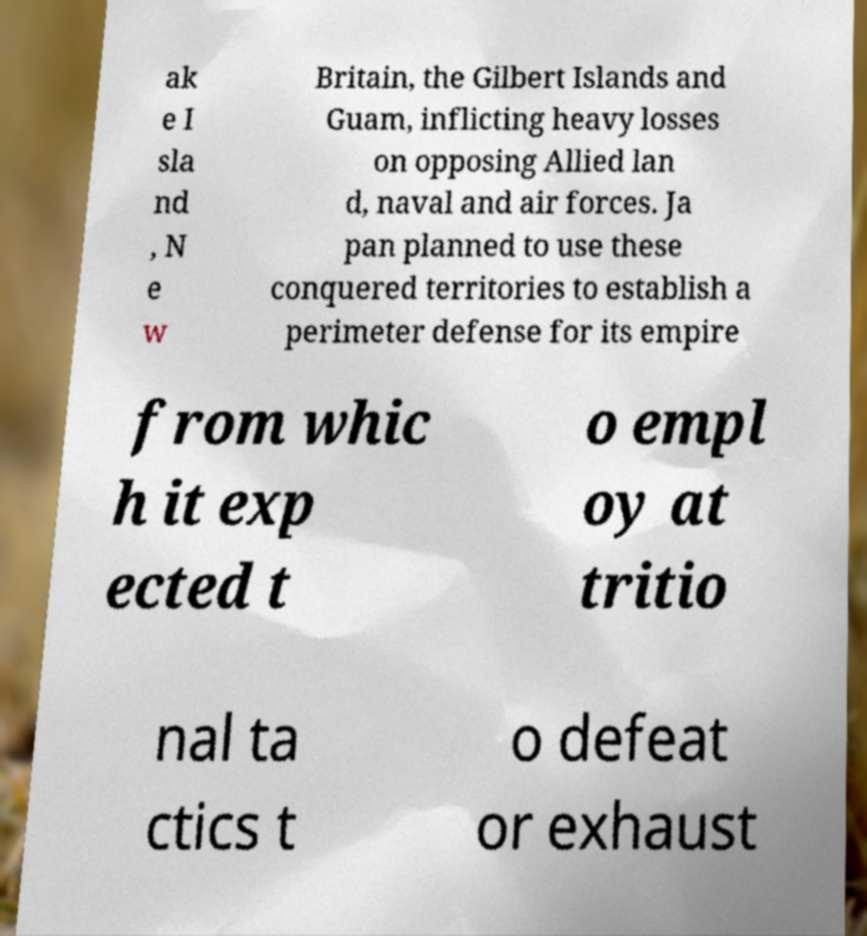There's text embedded in this image that I need extracted. Can you transcribe it verbatim? ak e I sla nd , N e w Britain, the Gilbert Islands and Guam, inflicting heavy losses on opposing Allied lan d, naval and air forces. Ja pan planned to use these conquered territories to establish a perimeter defense for its empire from whic h it exp ected t o empl oy at tritio nal ta ctics t o defeat or exhaust 